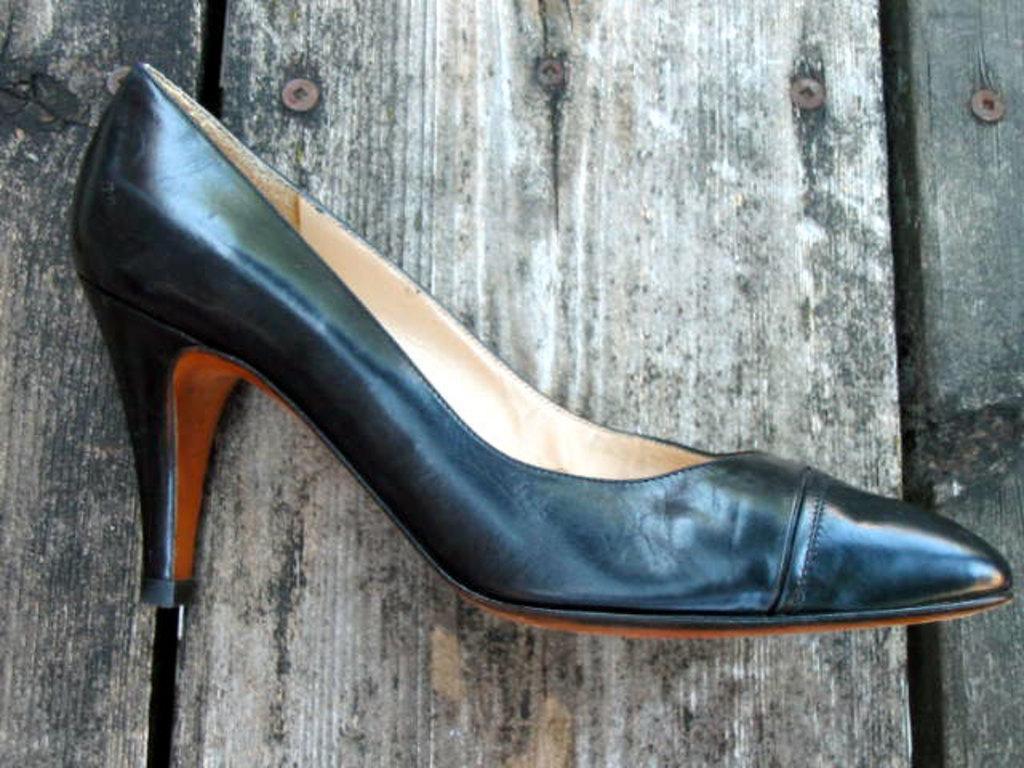In one or two sentences, can you explain what this image depicts? In the picture there is a footwear present on the table. 